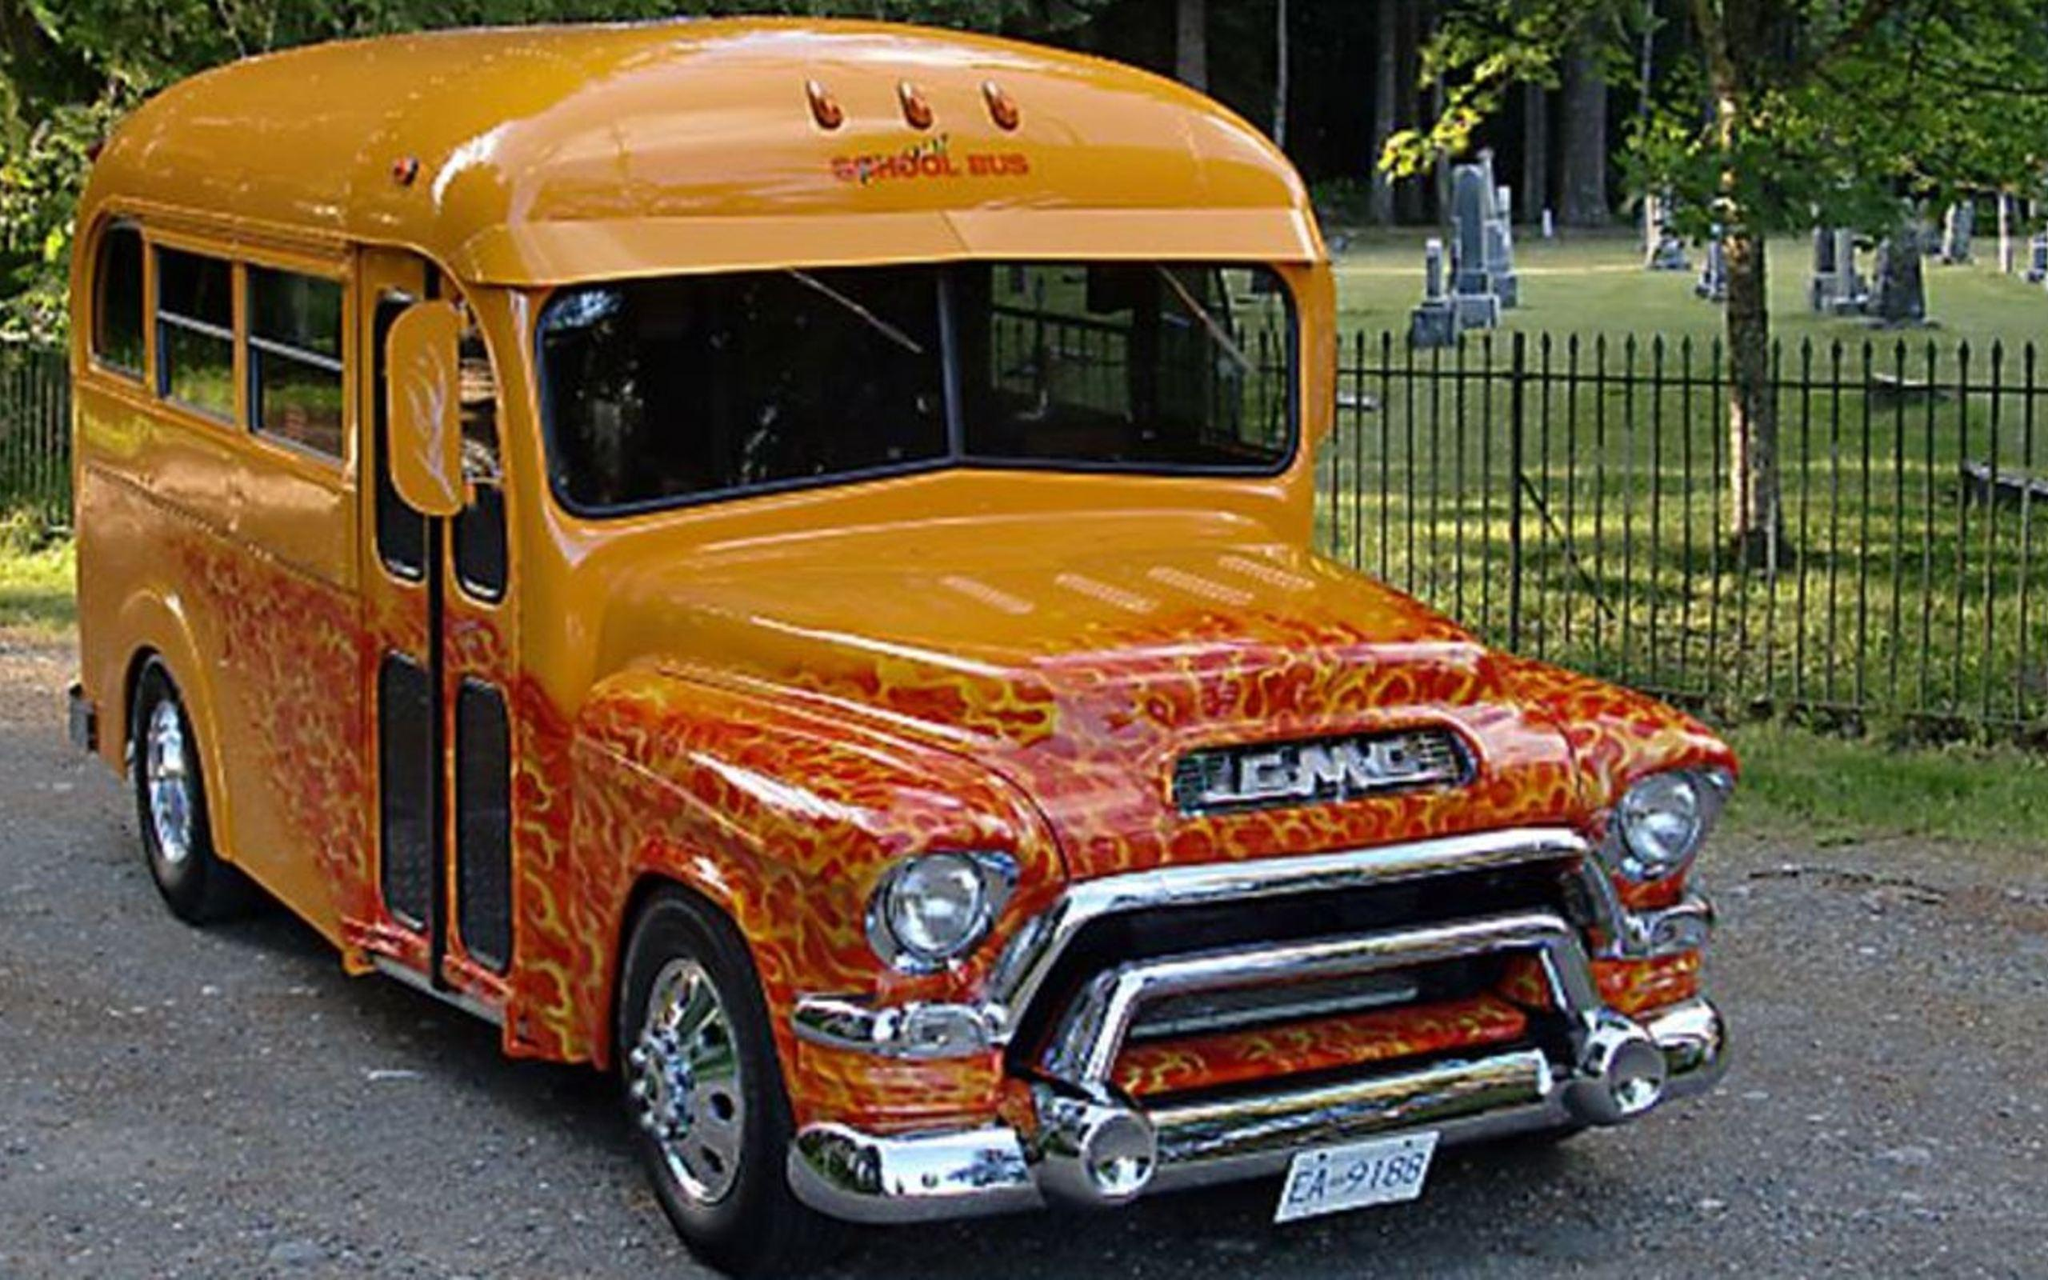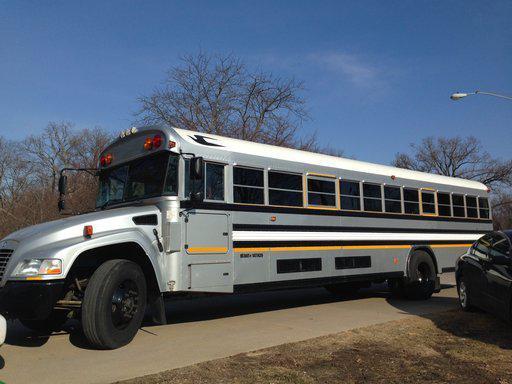The first image is the image on the left, the second image is the image on the right. Analyze the images presented: Is the assertion "The school bus on the left has the hood of a classic car, not of a school bus." valid? Answer yes or no. Yes. The first image is the image on the left, the second image is the image on the right. For the images shown, is this caption "The left image shows a classic-car-look short bus with three passenger windows on a side, a rounded top, and a scooped hood." true? Answer yes or no. Yes. 